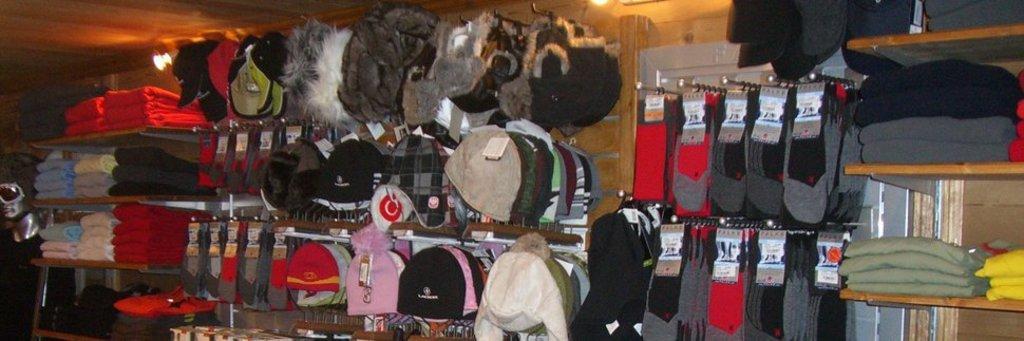Can you describe this image briefly? In the center of the image we can see caps, clothes, socks arranged in a rows. In the background we can see light and wall. 